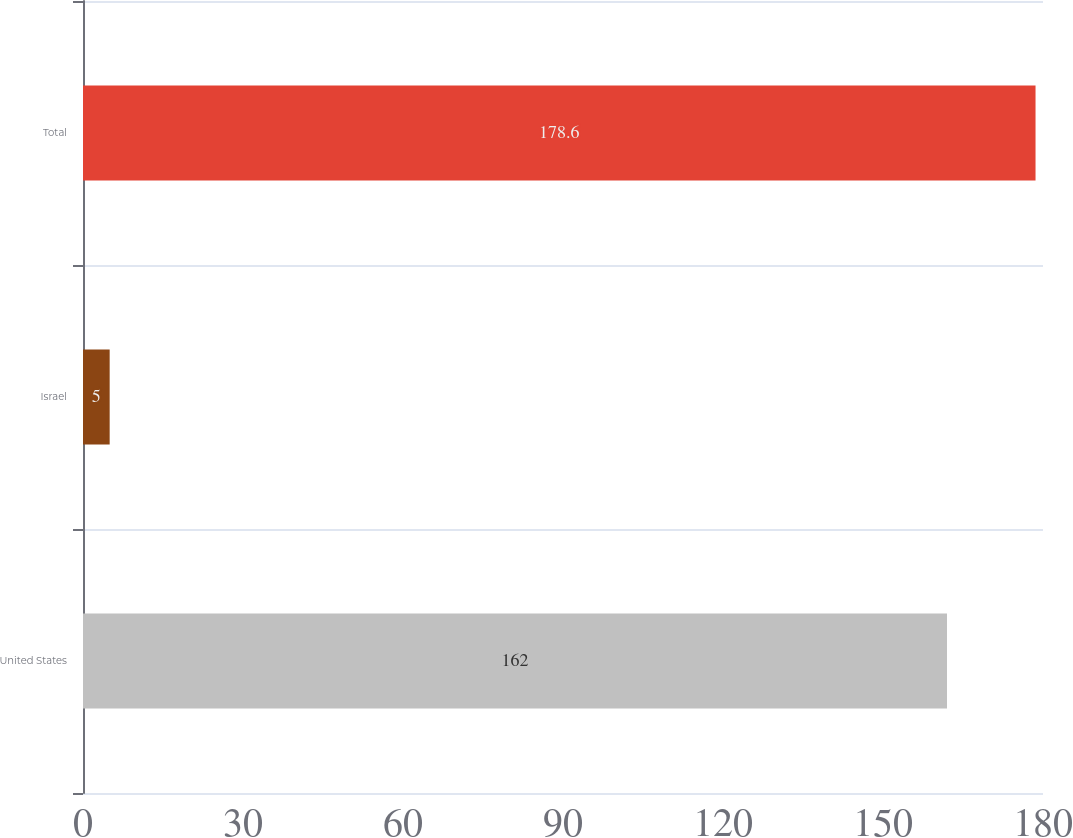Convert chart to OTSL. <chart><loc_0><loc_0><loc_500><loc_500><bar_chart><fcel>United States<fcel>Israel<fcel>Total<nl><fcel>162<fcel>5<fcel>178.6<nl></chart> 